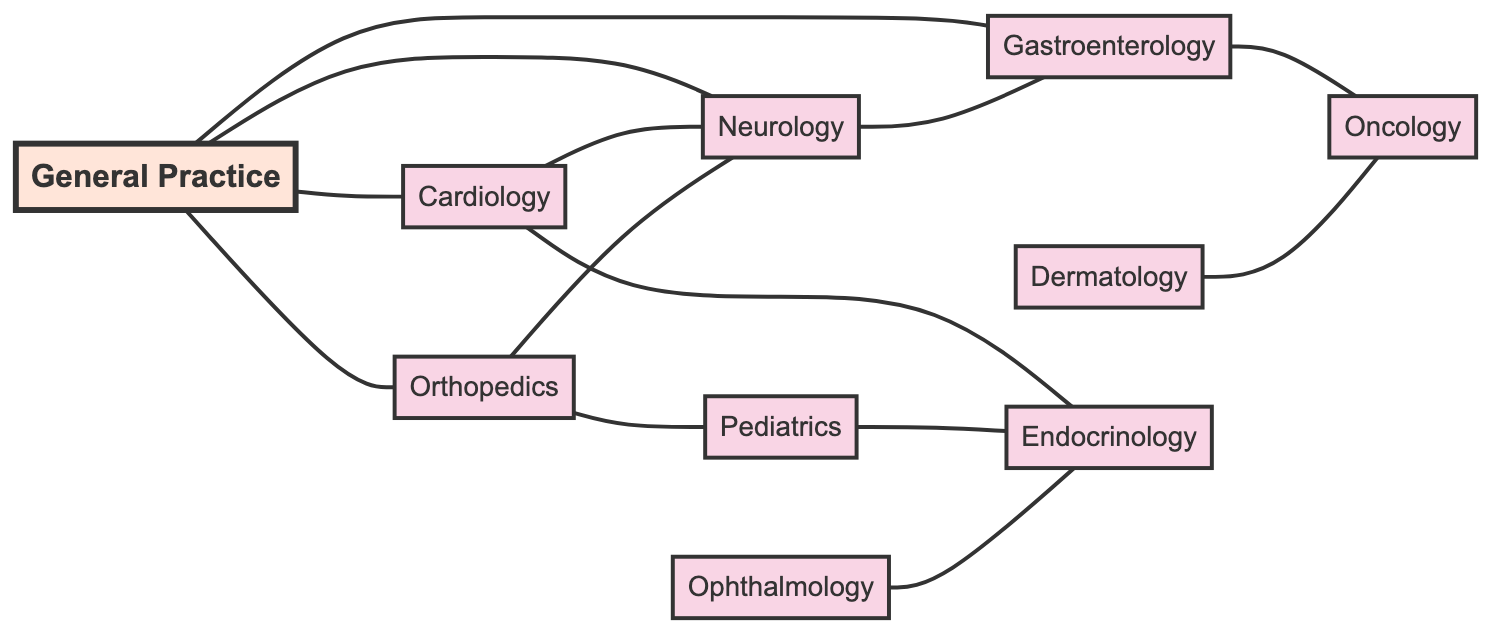What is the total number of specialties represented in the graph? The graph lists ten specialties in total: General Practice, Cardiology, Orthopedics, Neurology, Gastroenterology, Dermatology, Pediatrics, Oncology, Ophthalmology, and Endocrinology.
Answer: Ten Which specialty is connected to General Practice by a referral? The graph shows that General Practice has connections to several specialties: Cardiology, Orthopedics, Neurology, and Gastroenterology. Any of these can be valid answers, but one example is Cardiology.
Answer: Cardiology How many edges are there originating from Orthopedics? Looking at the connections originating from Orthopedics, there are two: one leading to Neurology and another leading to Pediatrics, resulting in two edges.
Answer: Two Which specialty is connected to both Gastroenterology and Oncology? The diagram indicates that Gastroenterology connects to Oncology through one direct edge. Hence, the specialty that connects both is Gastroenterology.
Answer: Gastroenterology Which specialty can refer patients to Endocrinology? From the graph, multiple specialties can refer to Endocrinology, including Cardiology, Pediatrics, and Ophthalmology. One example is Cardiology.
Answer: Cardiology How many total referral connections are made between Cardiology and Neurology? The graph outlines two connections: one from General Practice to Cardiology and another from Cardiology to Neurology. Therefore, there are two connections from General Practice to Neurology through Cardiology.
Answer: Two Which specialty has the highest number of connections? By assessing the connections in the diagram, Neurology has three connections (from General Practice, Cardiology, and Orthopedics), which is the highest in this context.
Answer: Neurology Is there a direct referral from Dermatology to Pediatrics? Checking the graph, there is no direct edge that connects Dermatology to Pediatrics as an undirected referral. They are not directly connected.
Answer: No How many specialties are reachable from General Practice? General Practice can refer patients to four different specialties: Cardiology, Orthopedics, Neurology, and Gastroenterology, making it four reachable specialties.
Answer: Four 